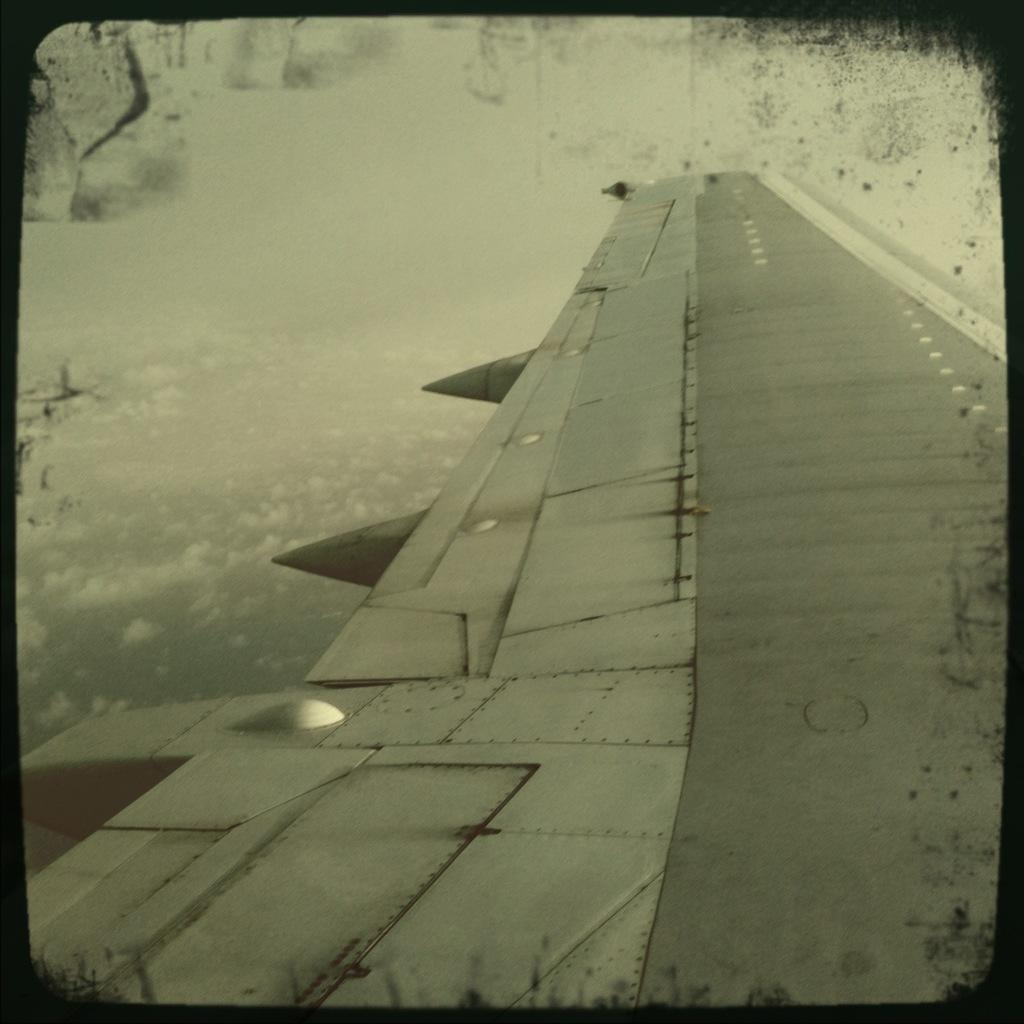What is the main subject of the picture? The main subject of the picture is an airplane wing. What is the color scheme of the picture? The picture is black and white. Can you tell me how many farm animals are visible in the picture? There are no farm animals present in the picture; it features an airplane wing. What type of writer is depicted in the picture? There is no writer depicted in the picture; it features an airplane wing. 